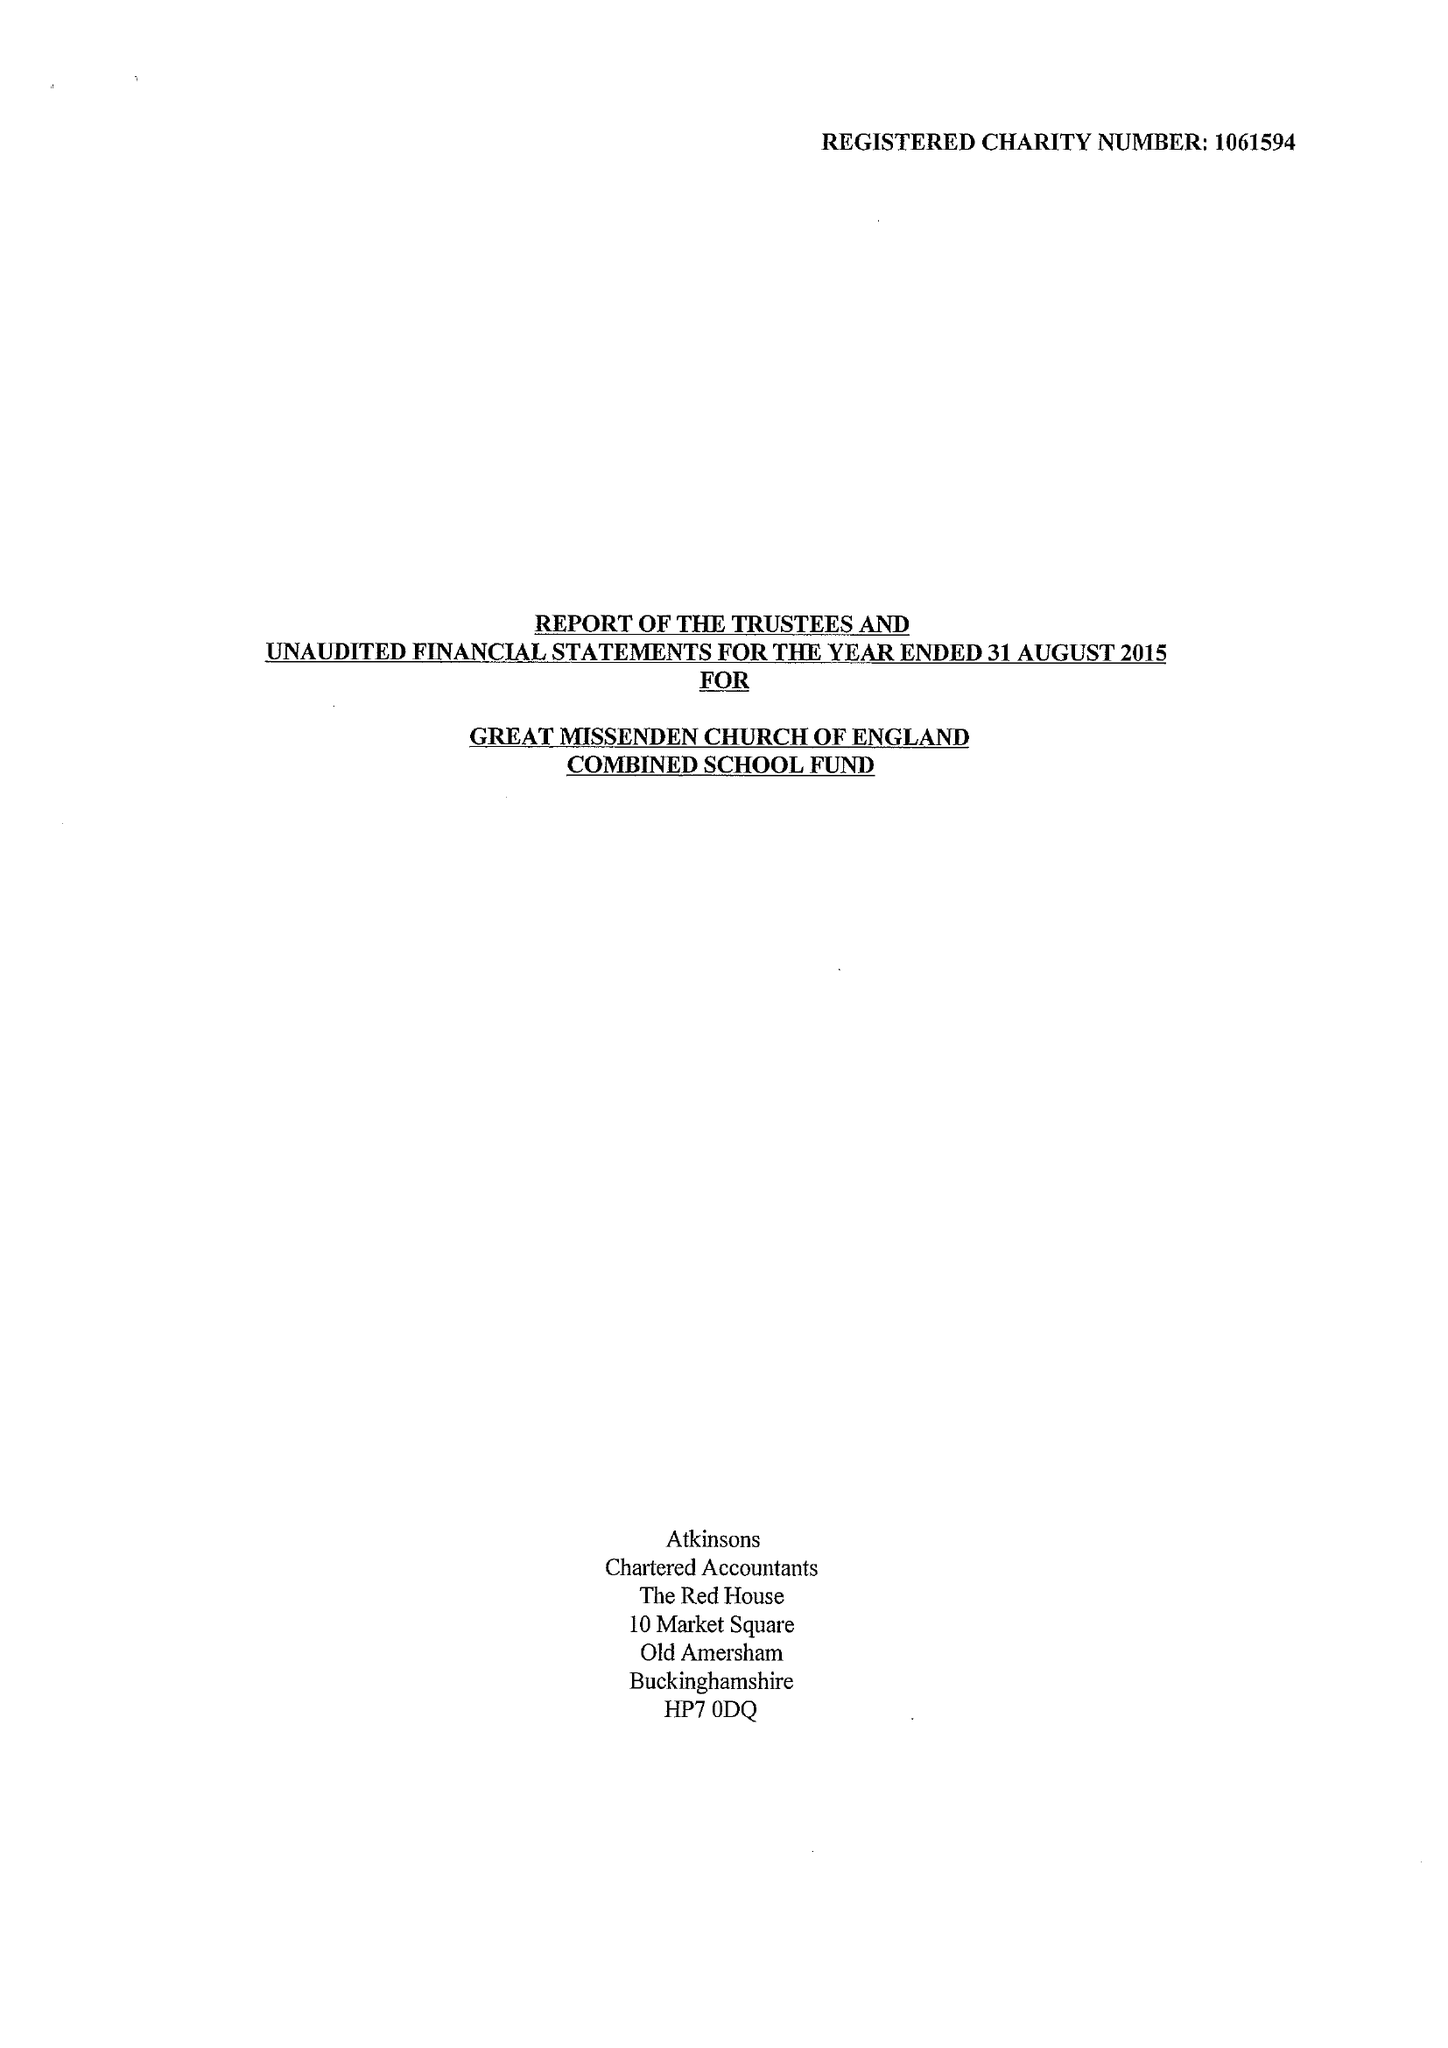What is the value for the spending_annually_in_british_pounds?
Answer the question using a single word or phrase. 214351.00 